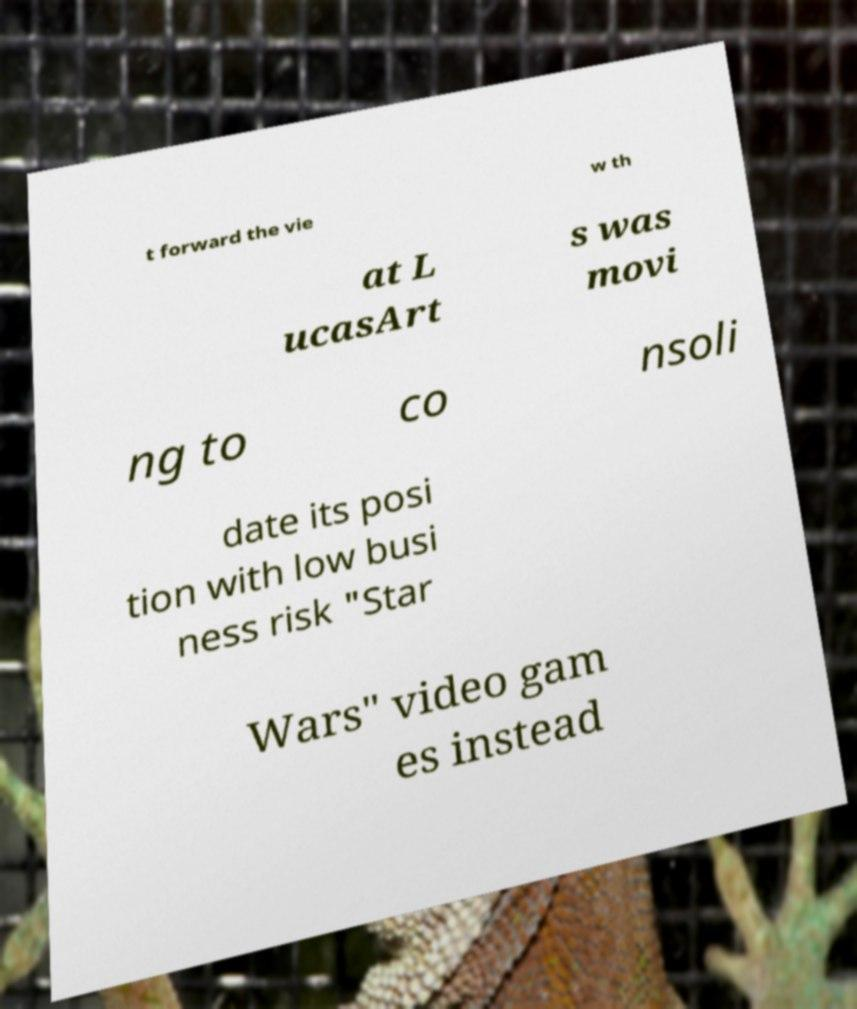Can you accurately transcribe the text from the provided image for me? t forward the vie w th at L ucasArt s was movi ng to co nsoli date its posi tion with low busi ness risk "Star Wars" video gam es instead 